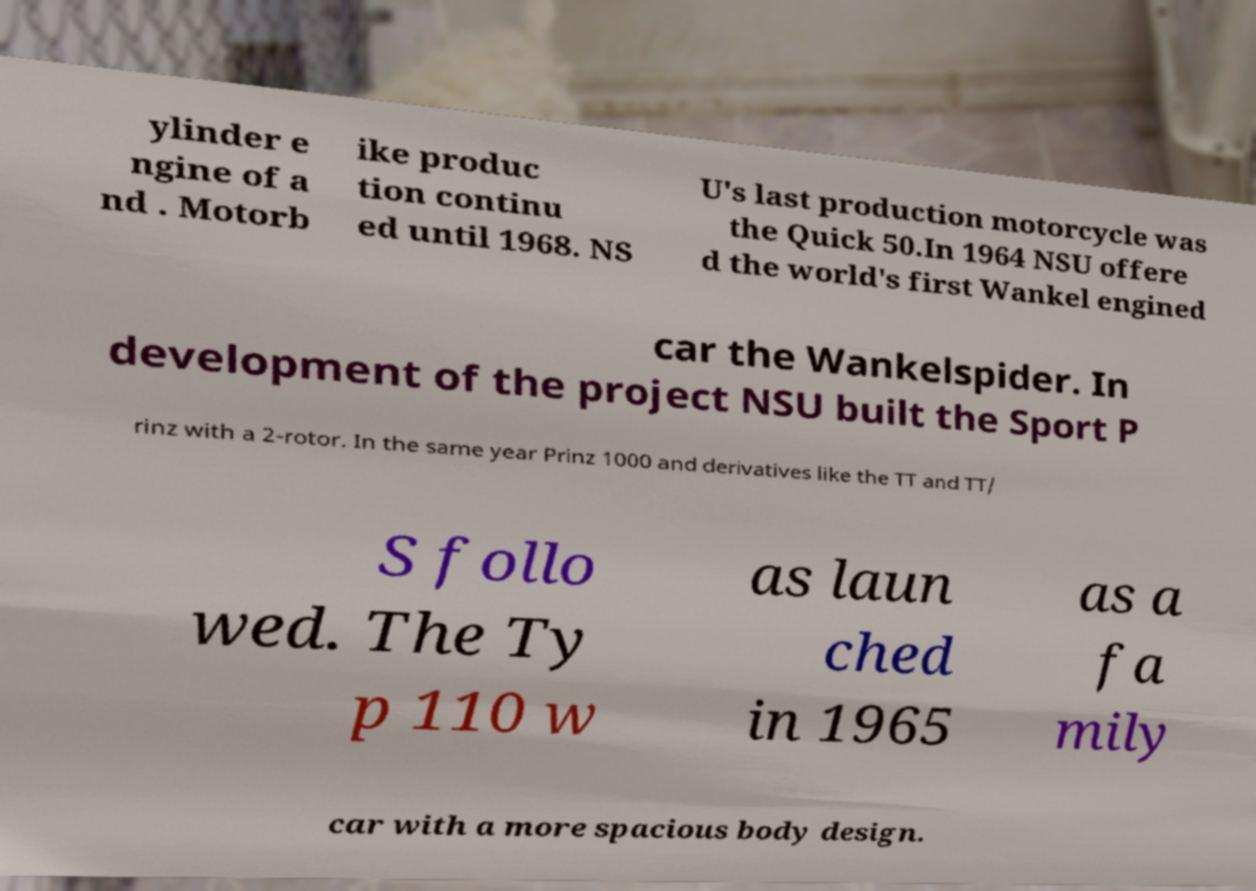What messages or text are displayed in this image? I need them in a readable, typed format. ylinder e ngine of a nd . Motorb ike produc tion continu ed until 1968. NS U's last production motorcycle was the Quick 50.In 1964 NSU offere d the world's first Wankel engined car the Wankelspider. In development of the project NSU built the Sport P rinz with a 2-rotor. In the same year Prinz 1000 and derivatives like the TT and TT/ S follo wed. The Ty p 110 w as laun ched in 1965 as a fa mily car with a more spacious body design. 